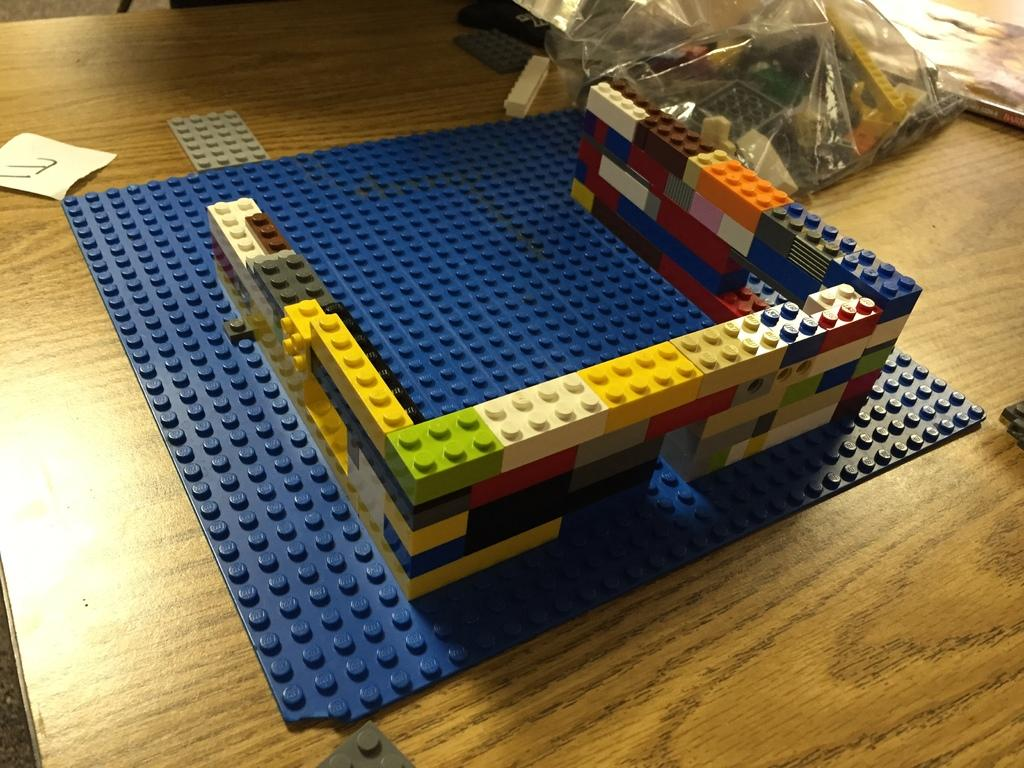What type of game is visible in the image? There is a toy game in the image. What else can be seen on the table in the image? There is a book and a plastic cover visible on the table in the image. Where was the image taken? The image was taken in a room. What word is written on the rabbit's ear in the image? There is no rabbit present in the image, so it is not possible to answer that question. 